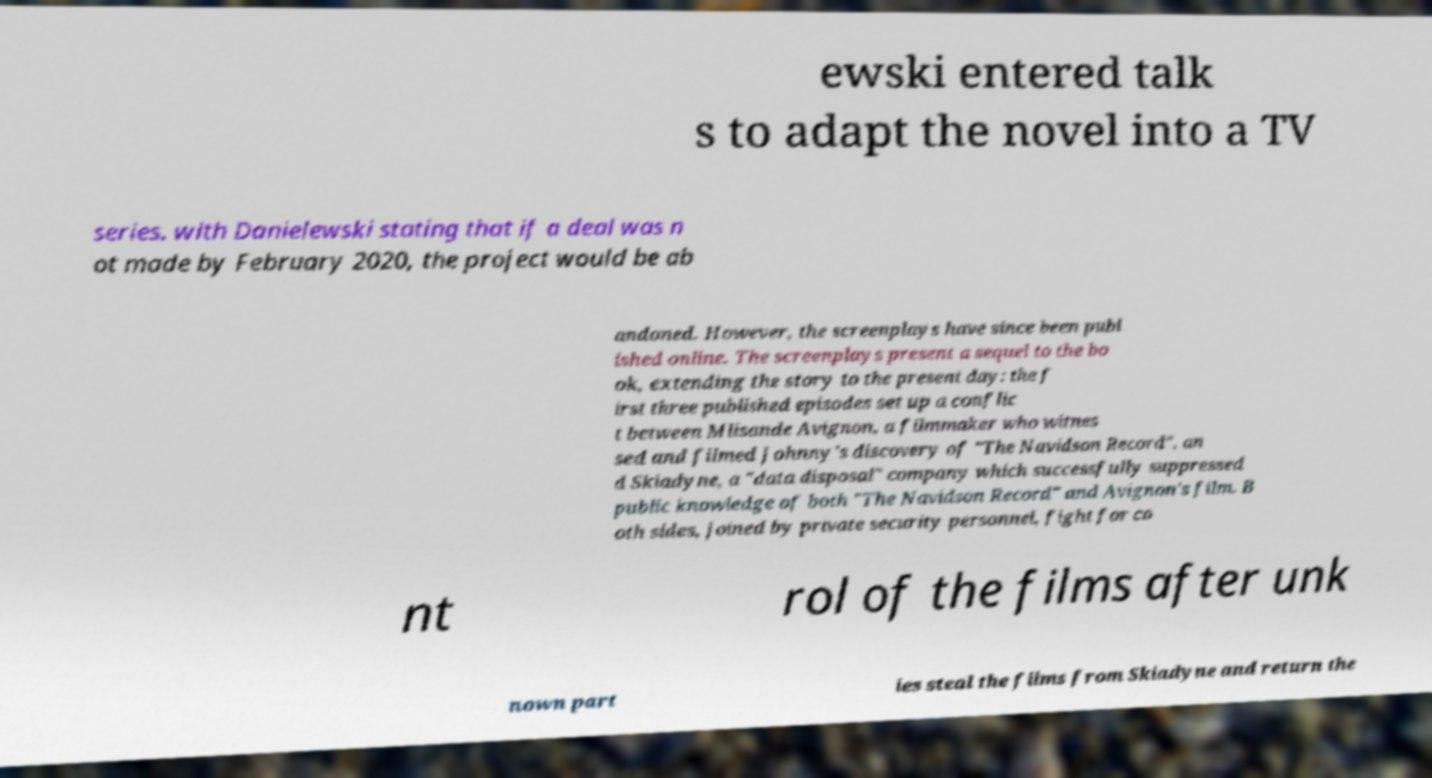Can you read and provide the text displayed in the image?This photo seems to have some interesting text. Can you extract and type it out for me? ewski entered talk s to adapt the novel into a TV series. with Danielewski stating that if a deal was n ot made by February 2020, the project would be ab andoned. However, the screenplays have since been publ ished online. The screenplays present a sequel to the bo ok, extending the story to the present day: the f irst three published episodes set up a conflic t between Mlisande Avignon, a filmmaker who witnes sed and filmed Johnny's discovery of "The Navidson Record", an d Skiadyne, a "data disposal" company which successfully suppressed public knowledge of both "The Navidson Record" and Avignon's film. B oth sides, joined by private security personnel, fight for co nt rol of the films after unk nown part ies steal the films from Skiadyne and return the 